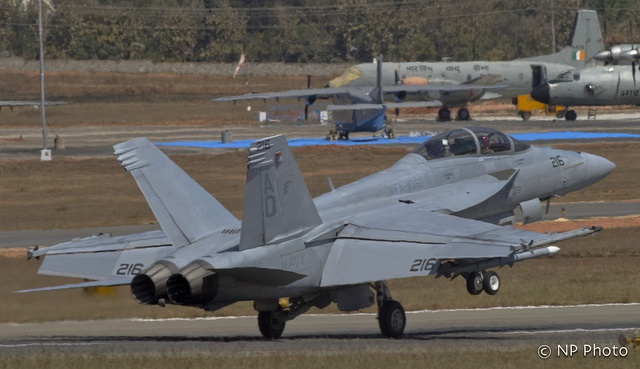Describe the objects in this image and their specific colors. I can see airplane in gray and black tones, airplane in gray, darkgray, and black tones, airplane in gray, black, darkgray, and lightgray tones, airplane in gray and black tones, and people in gray, black, and purple tones in this image. 